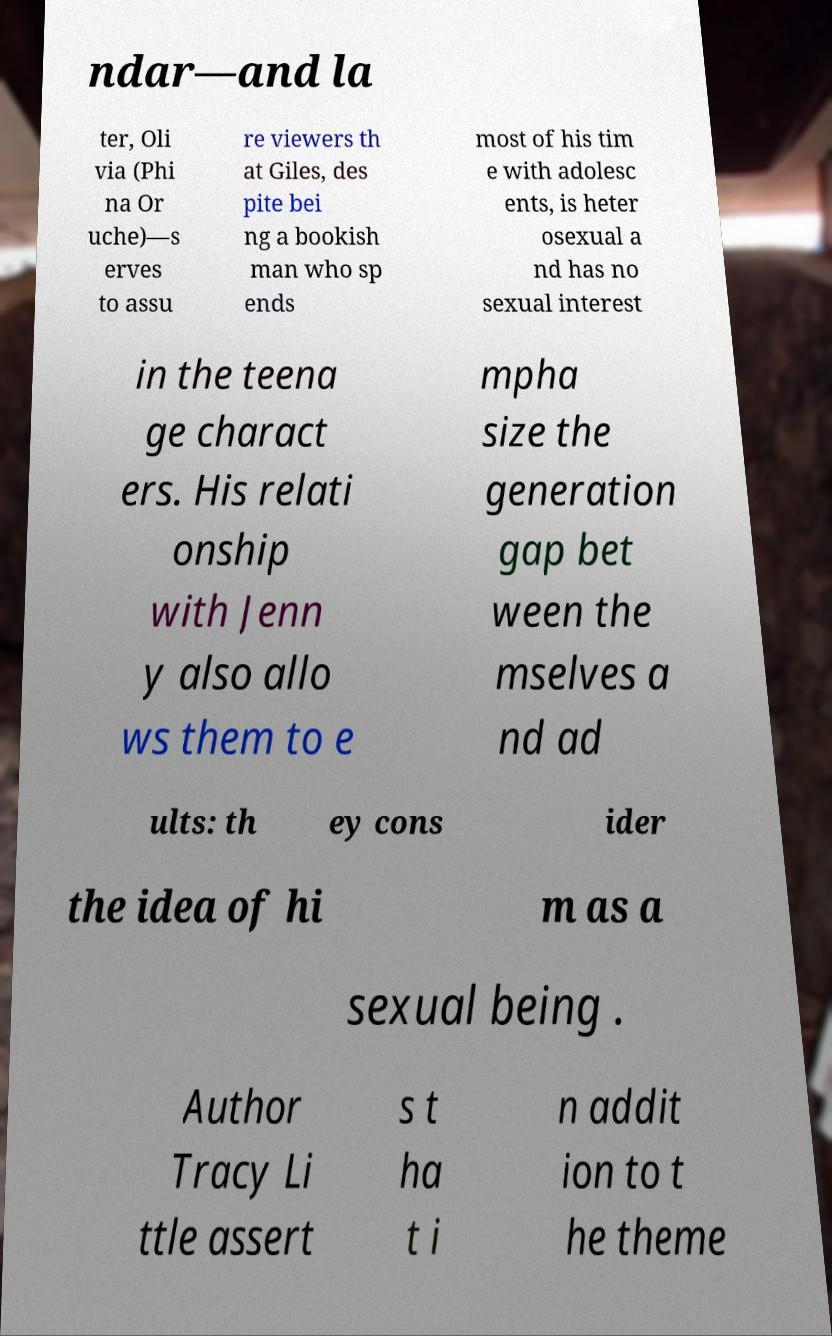Could you assist in decoding the text presented in this image and type it out clearly? ndar—and la ter, Oli via (Phi na Or uche)—s erves to assu re viewers th at Giles, des pite bei ng a bookish man who sp ends most of his tim e with adolesc ents, is heter osexual a nd has no sexual interest in the teena ge charact ers. His relati onship with Jenn y also allo ws them to e mpha size the generation gap bet ween the mselves a nd ad ults: th ey cons ider the idea of hi m as a sexual being . Author Tracy Li ttle assert s t ha t i n addit ion to t he theme 